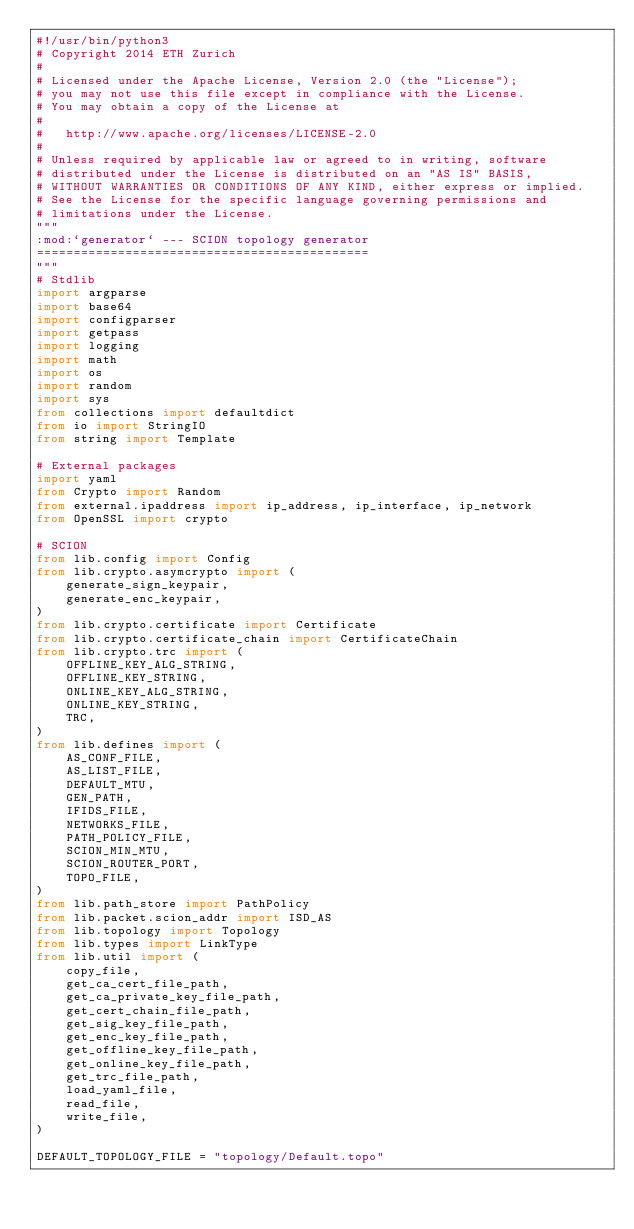<code> <loc_0><loc_0><loc_500><loc_500><_Python_>#!/usr/bin/python3
# Copyright 2014 ETH Zurich
#
# Licensed under the Apache License, Version 2.0 (the "License");
# you may not use this file except in compliance with the License.
# You may obtain a copy of the License at
#
#   http://www.apache.org/licenses/LICENSE-2.0
#
# Unless required by applicable law or agreed to in writing, software
# distributed under the License is distributed on an "AS IS" BASIS,
# WITHOUT WARRANTIES OR CONDITIONS OF ANY KIND, either express or implied.
# See the License for the specific language governing permissions and
# limitations under the License.
"""
:mod:`generator` --- SCION topology generator
=============================================
"""
# Stdlib
import argparse
import base64
import configparser
import getpass
import logging
import math
import os
import random
import sys
from collections import defaultdict
from io import StringIO
from string import Template

# External packages
import yaml
from Crypto import Random
from external.ipaddress import ip_address, ip_interface, ip_network
from OpenSSL import crypto

# SCION
from lib.config import Config
from lib.crypto.asymcrypto import (
    generate_sign_keypair,
    generate_enc_keypair,
)
from lib.crypto.certificate import Certificate
from lib.crypto.certificate_chain import CertificateChain
from lib.crypto.trc import (
    OFFLINE_KEY_ALG_STRING,
    OFFLINE_KEY_STRING,
    ONLINE_KEY_ALG_STRING,
    ONLINE_KEY_STRING,
    TRC,
)
from lib.defines import (
    AS_CONF_FILE,
    AS_LIST_FILE,
    DEFAULT_MTU,
    GEN_PATH,
    IFIDS_FILE,
    NETWORKS_FILE,
    PATH_POLICY_FILE,
    SCION_MIN_MTU,
    SCION_ROUTER_PORT,
    TOPO_FILE,
)
from lib.path_store import PathPolicy
from lib.packet.scion_addr import ISD_AS
from lib.topology import Topology
from lib.types import LinkType
from lib.util import (
    copy_file,
    get_ca_cert_file_path,
    get_ca_private_key_file_path,
    get_cert_chain_file_path,
    get_sig_key_file_path,
    get_enc_key_file_path,
    get_offline_key_file_path,
    get_online_key_file_path,
    get_trc_file_path,
    load_yaml_file,
    read_file,
    write_file,
)

DEFAULT_TOPOLOGY_FILE = "topology/Default.topo"</code> 